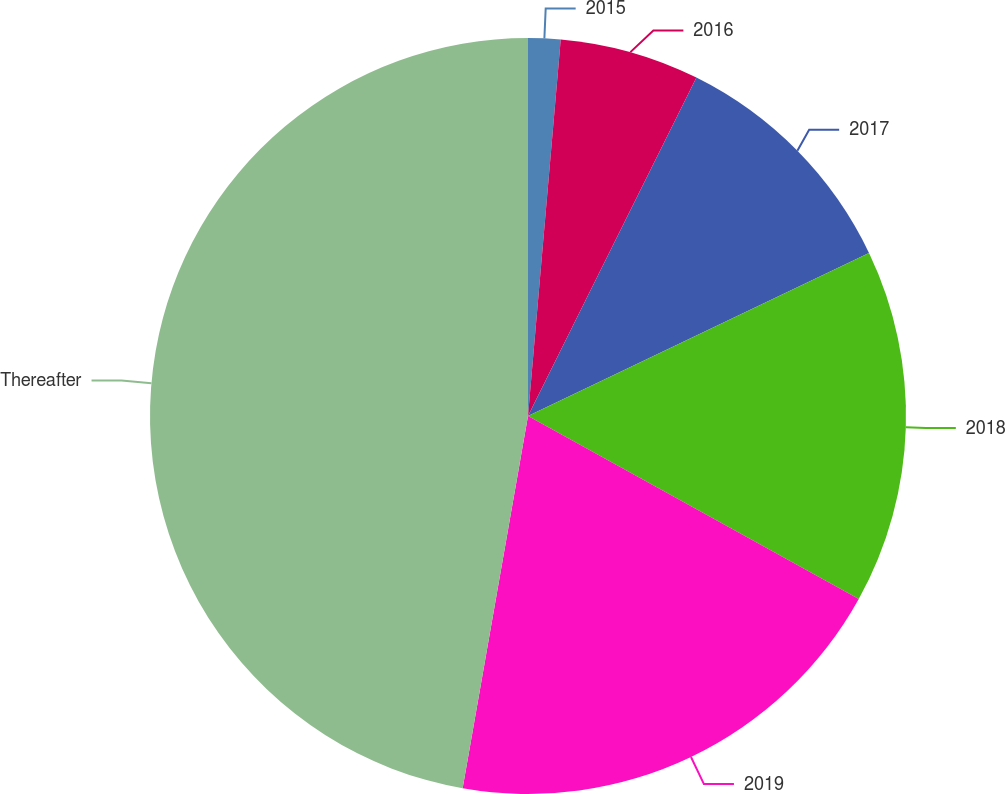Convert chart to OTSL. <chart><loc_0><loc_0><loc_500><loc_500><pie_chart><fcel>2015<fcel>2016<fcel>2017<fcel>2018<fcel>2019<fcel>Thereafter<nl><fcel>1.38%<fcel>5.97%<fcel>10.55%<fcel>15.14%<fcel>19.72%<fcel>47.23%<nl></chart> 